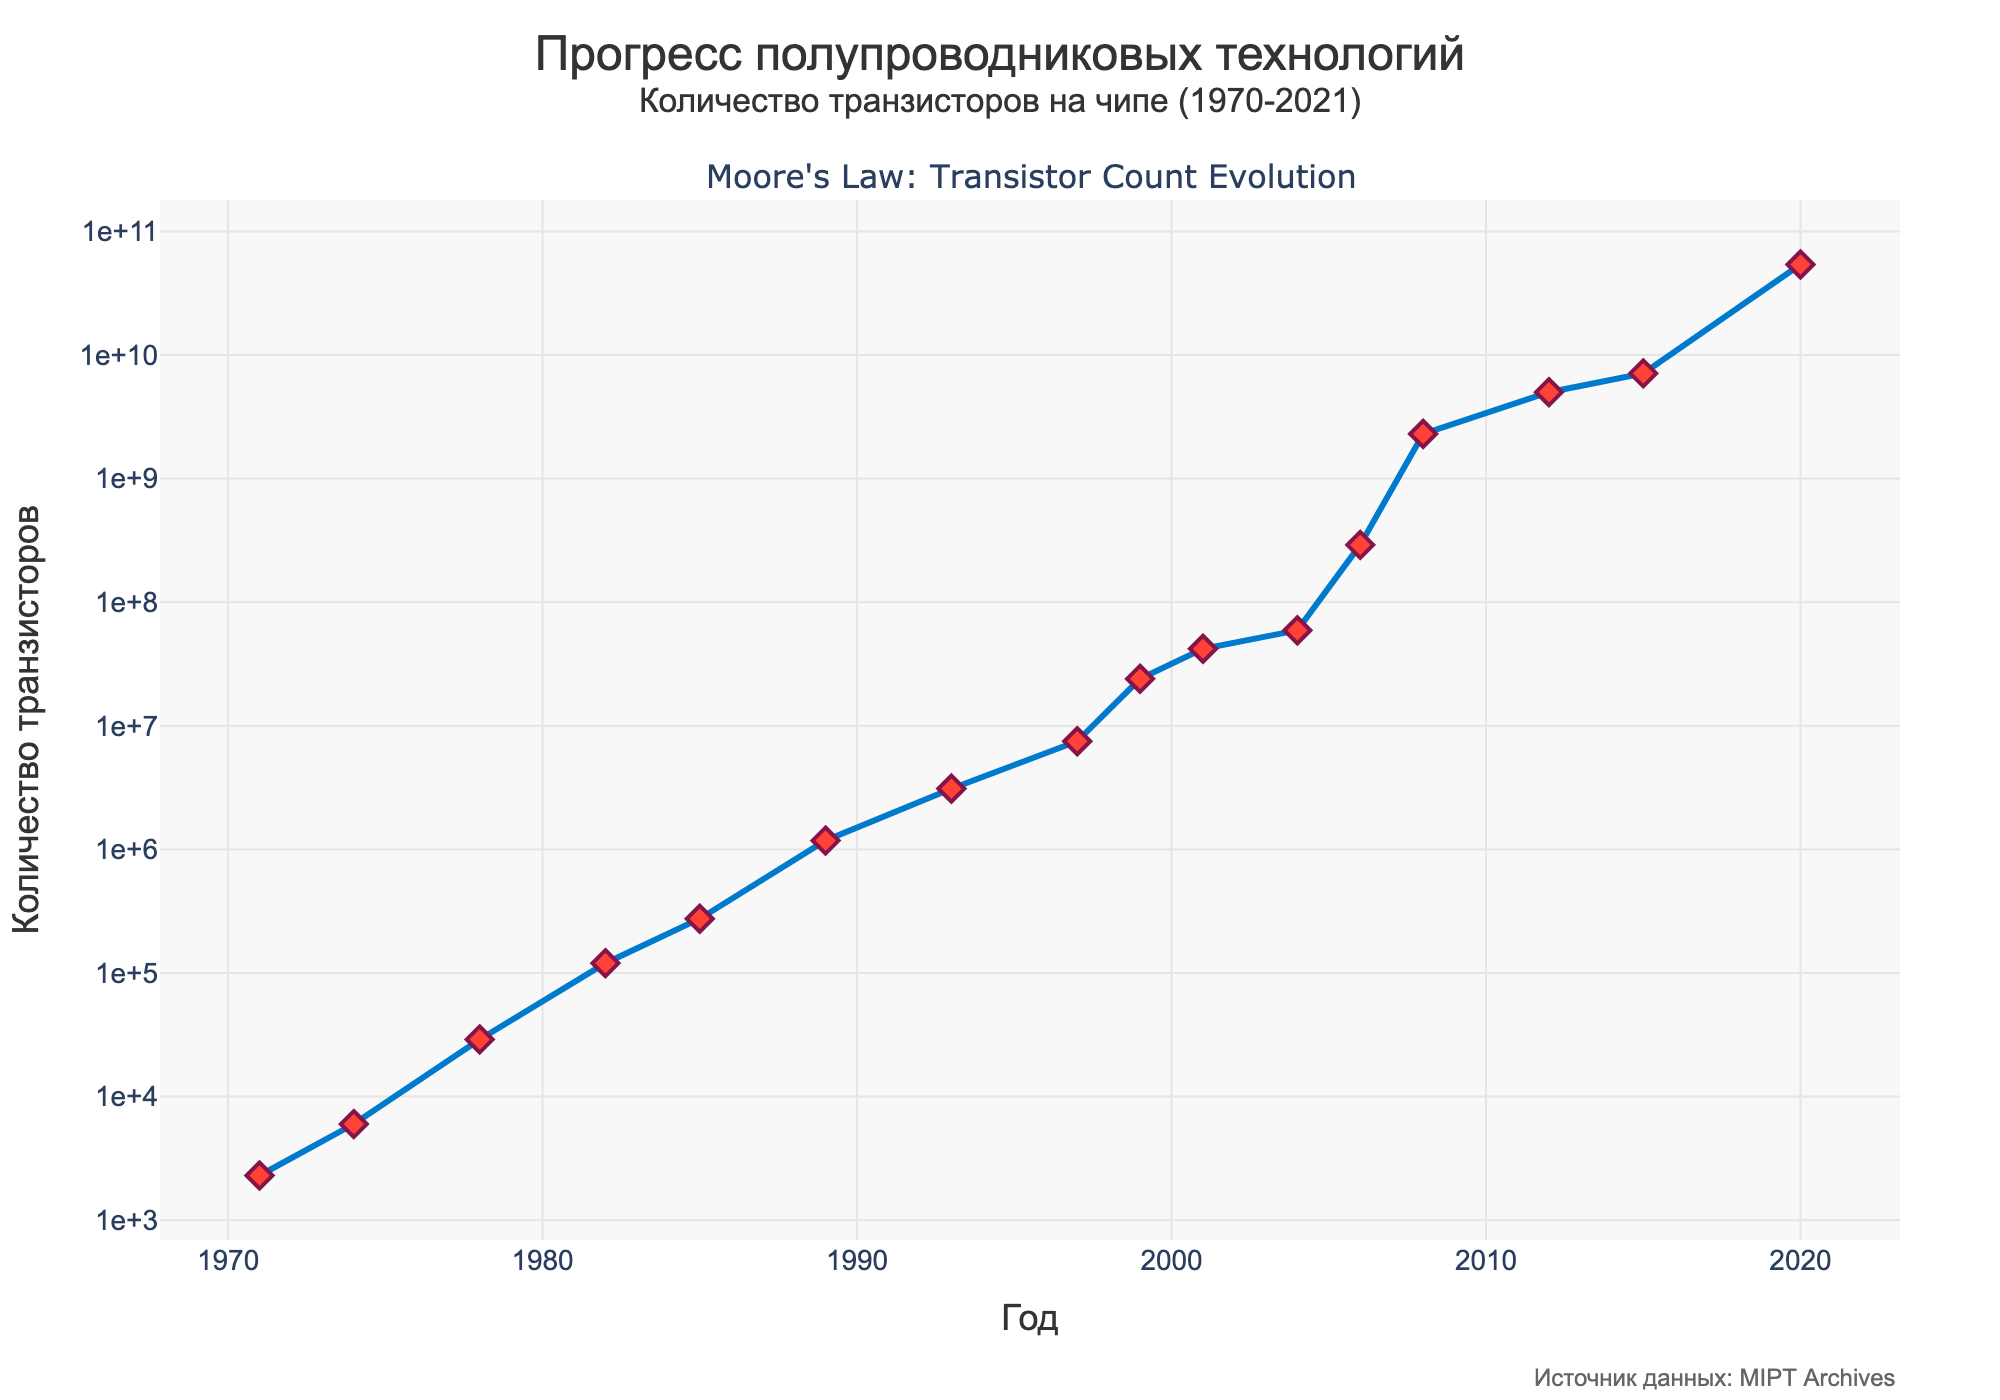What's the title of the figure? The title is at the top of the figure and reads "Прогресс полупроводниковых технологий" with a subtitle "Количество транзисторов на чипе (1970-2021)"
Answer: Прогресс полупроводниковых технологий What is the x-axis representing? The x-axis is labeled "Год", which translates to "Year" in English, indicating it represents the years from 1970 to 2021.
Answer: Year What type of scale is used for the y-axis? The y-axis uses a logarithmic scale, as indicated in the plot description and by the evenly spaced tick marks that increase exponentially.
Answer: Logarithmic scale How many data points are there in the figure? By counting the markers on the line plot, we can see there are 16 data points.
Answer: 16 Which year marks the first major increase in transistor count? There is a noticeable increase in the slope of the line around 2006, where the transistor count jumps significantly.
Answer: 2006 Compare the transistor count between 2001 and 2004. Which year has the higher count and by how much? In 2001, the transistor count is 42,000,000, while in 2004, it is 59,200,000. The difference between them is 59,200,000 - 42,000,000 = 17,200,000.
Answer: 2004 by 17,200,000 What is the approximate transistor count in 1999? From the figure, the transistor count in 1999 is approximately 24,000,000.
Answer: 24,000,000 What trend do you observe between the years 1989 and 1997? Between 1989 and 1997, the transistor count consistently increases from 1,180,000 to 7,500,000, showing a clear upward trend.
Answer: Upward trend By what factor did the transistor count increase from 1982 to 1989? In 1982, the count is 120,000, and in 1989, it is 1,180,000. Dividing 1,180,000 by 120,000 gives a factor of roughly 9.83.
Answer: Factor of 9.83 What significant change in trend can you see in the plot? Around 2006, there is a marked increase in the slope, indicating a rapid rise in the transistor count, which significantly increases the rate of growth.
Answer: Rapid rise after 2006 